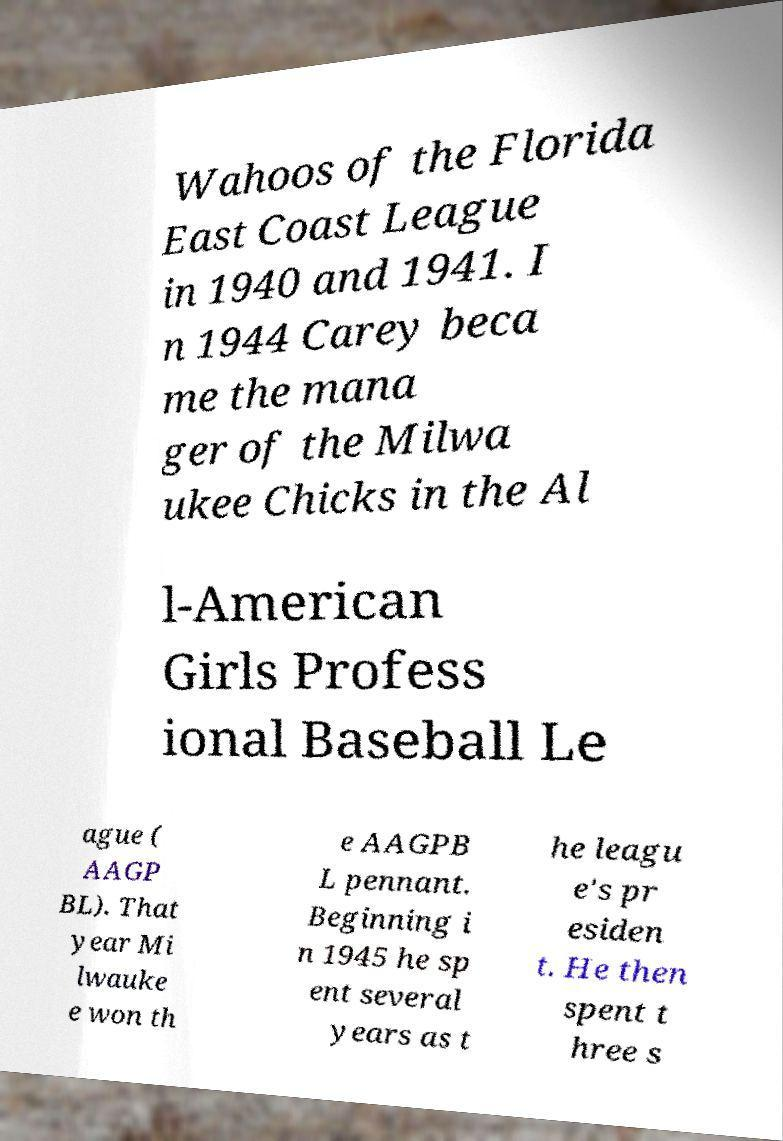For documentation purposes, I need the text within this image transcribed. Could you provide that? Wahoos of the Florida East Coast League in 1940 and 1941. I n 1944 Carey beca me the mana ger of the Milwa ukee Chicks in the Al l-American Girls Profess ional Baseball Le ague ( AAGP BL). That year Mi lwauke e won th e AAGPB L pennant. Beginning i n 1945 he sp ent several years as t he leagu e's pr esiden t. He then spent t hree s 